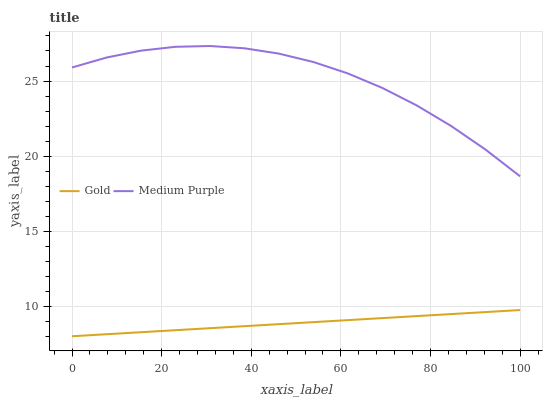Does Gold have the minimum area under the curve?
Answer yes or no. Yes. Does Medium Purple have the maximum area under the curve?
Answer yes or no. Yes. Does Gold have the maximum area under the curve?
Answer yes or no. No. Is Gold the smoothest?
Answer yes or no. Yes. Is Medium Purple the roughest?
Answer yes or no. Yes. Is Gold the roughest?
Answer yes or no. No. Does Gold have the lowest value?
Answer yes or no. Yes. Does Medium Purple have the highest value?
Answer yes or no. Yes. Does Gold have the highest value?
Answer yes or no. No. Is Gold less than Medium Purple?
Answer yes or no. Yes. Is Medium Purple greater than Gold?
Answer yes or no. Yes. Does Gold intersect Medium Purple?
Answer yes or no. No. 